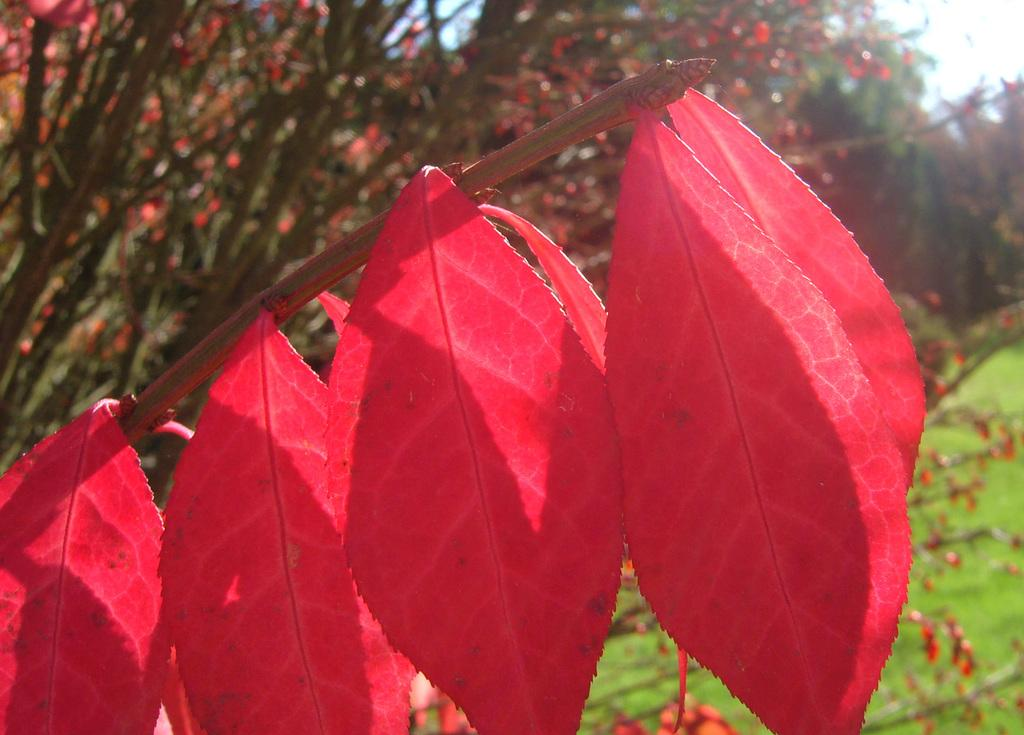What type of leaves can be seen on the tree in the image? The leaves of the tree in the image are red in color. What else can be seen in the background of the image? There are trees and the sky visible in the background of the image. What is on the ground in the image? There is grass on the ground in the image. Where is the curtain located in the image? There is no curtain present in the image. What type of toys can be seen on the grass in the image? There are no toys present in the image; it only features a tree with red leaves, grass, and the sky in the background. 